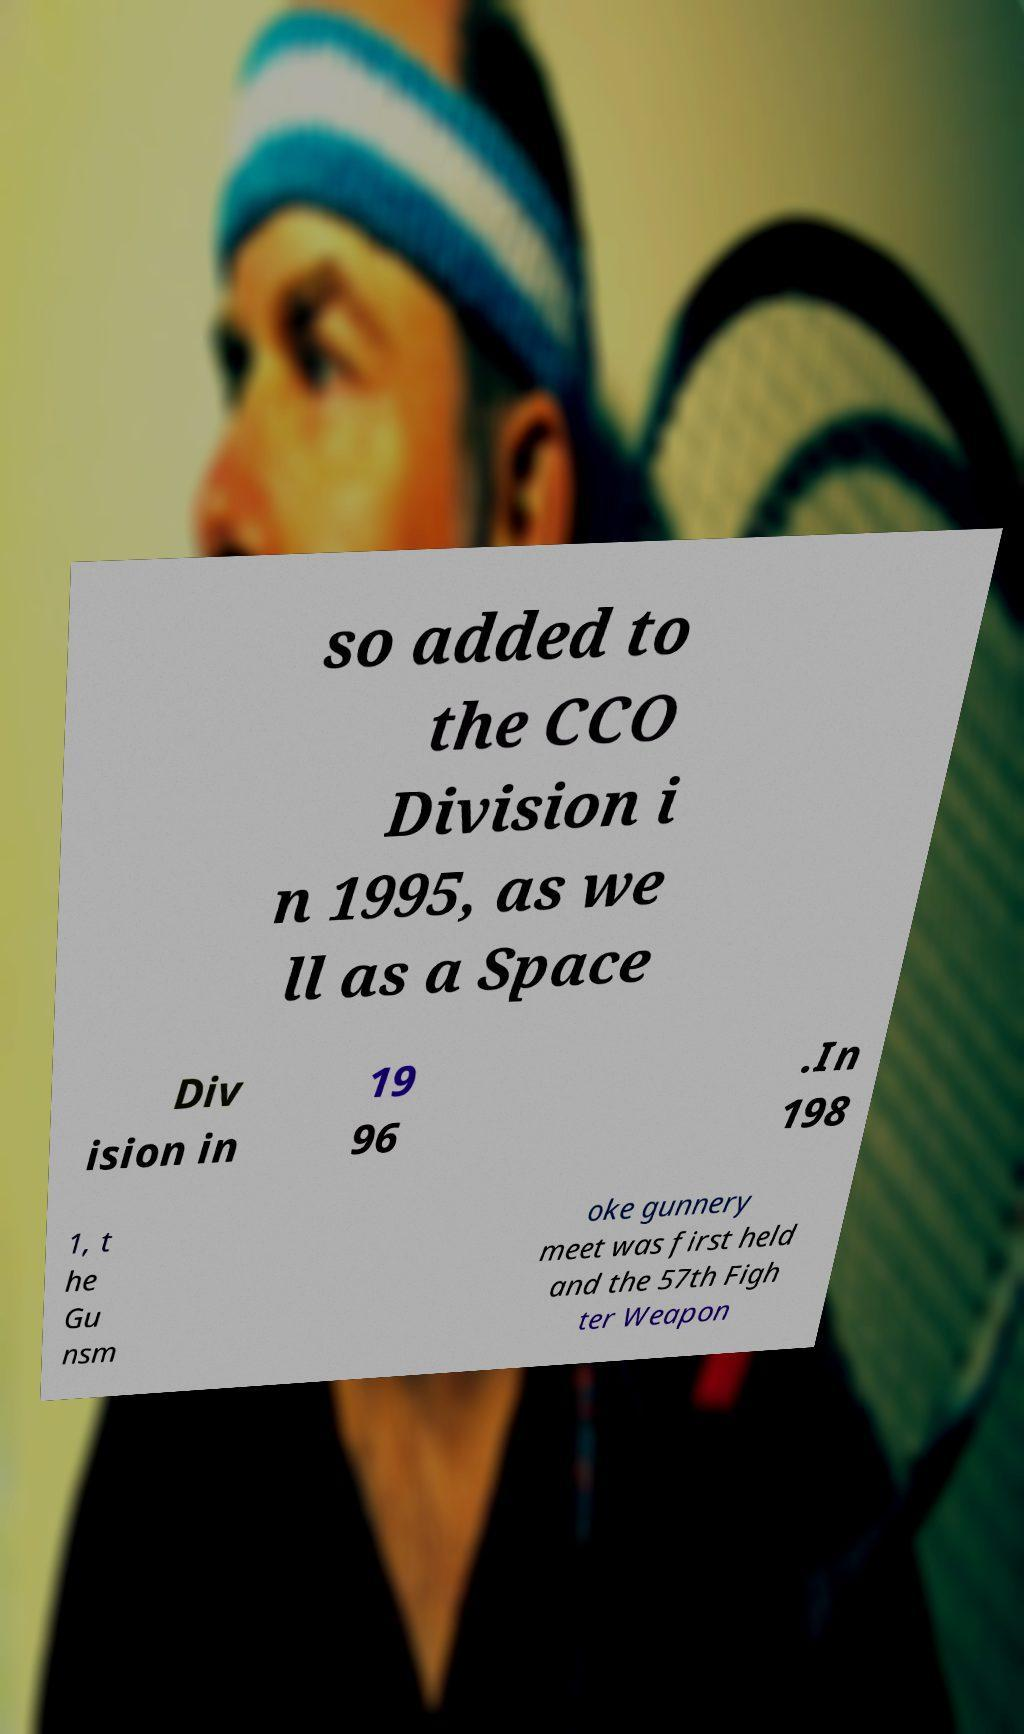Could you assist in decoding the text presented in this image and type it out clearly? so added to the CCO Division i n 1995, as we ll as a Space Div ision in 19 96 .In 198 1, t he Gu nsm oke gunnery meet was first held and the 57th Figh ter Weapon 